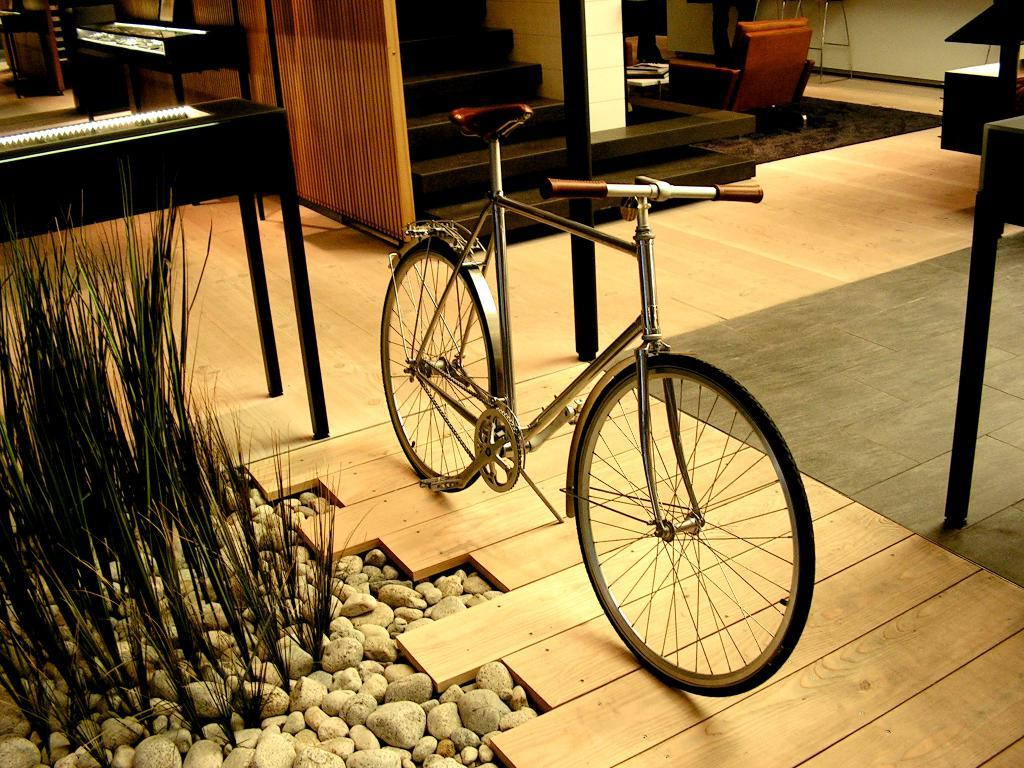What is the main mode of transportation in the image? There is a cycle in the image. What can be seen on the left side of the image? There are plants and stones on the left side of the image. What architectural feature is in the middle of the image? There is a staircase in the middle of the image. What type of fact can be seen floating on the water near the dock in the image? There is no dock or water present in the image; it features a cycle, plants, stones, and a staircase. 